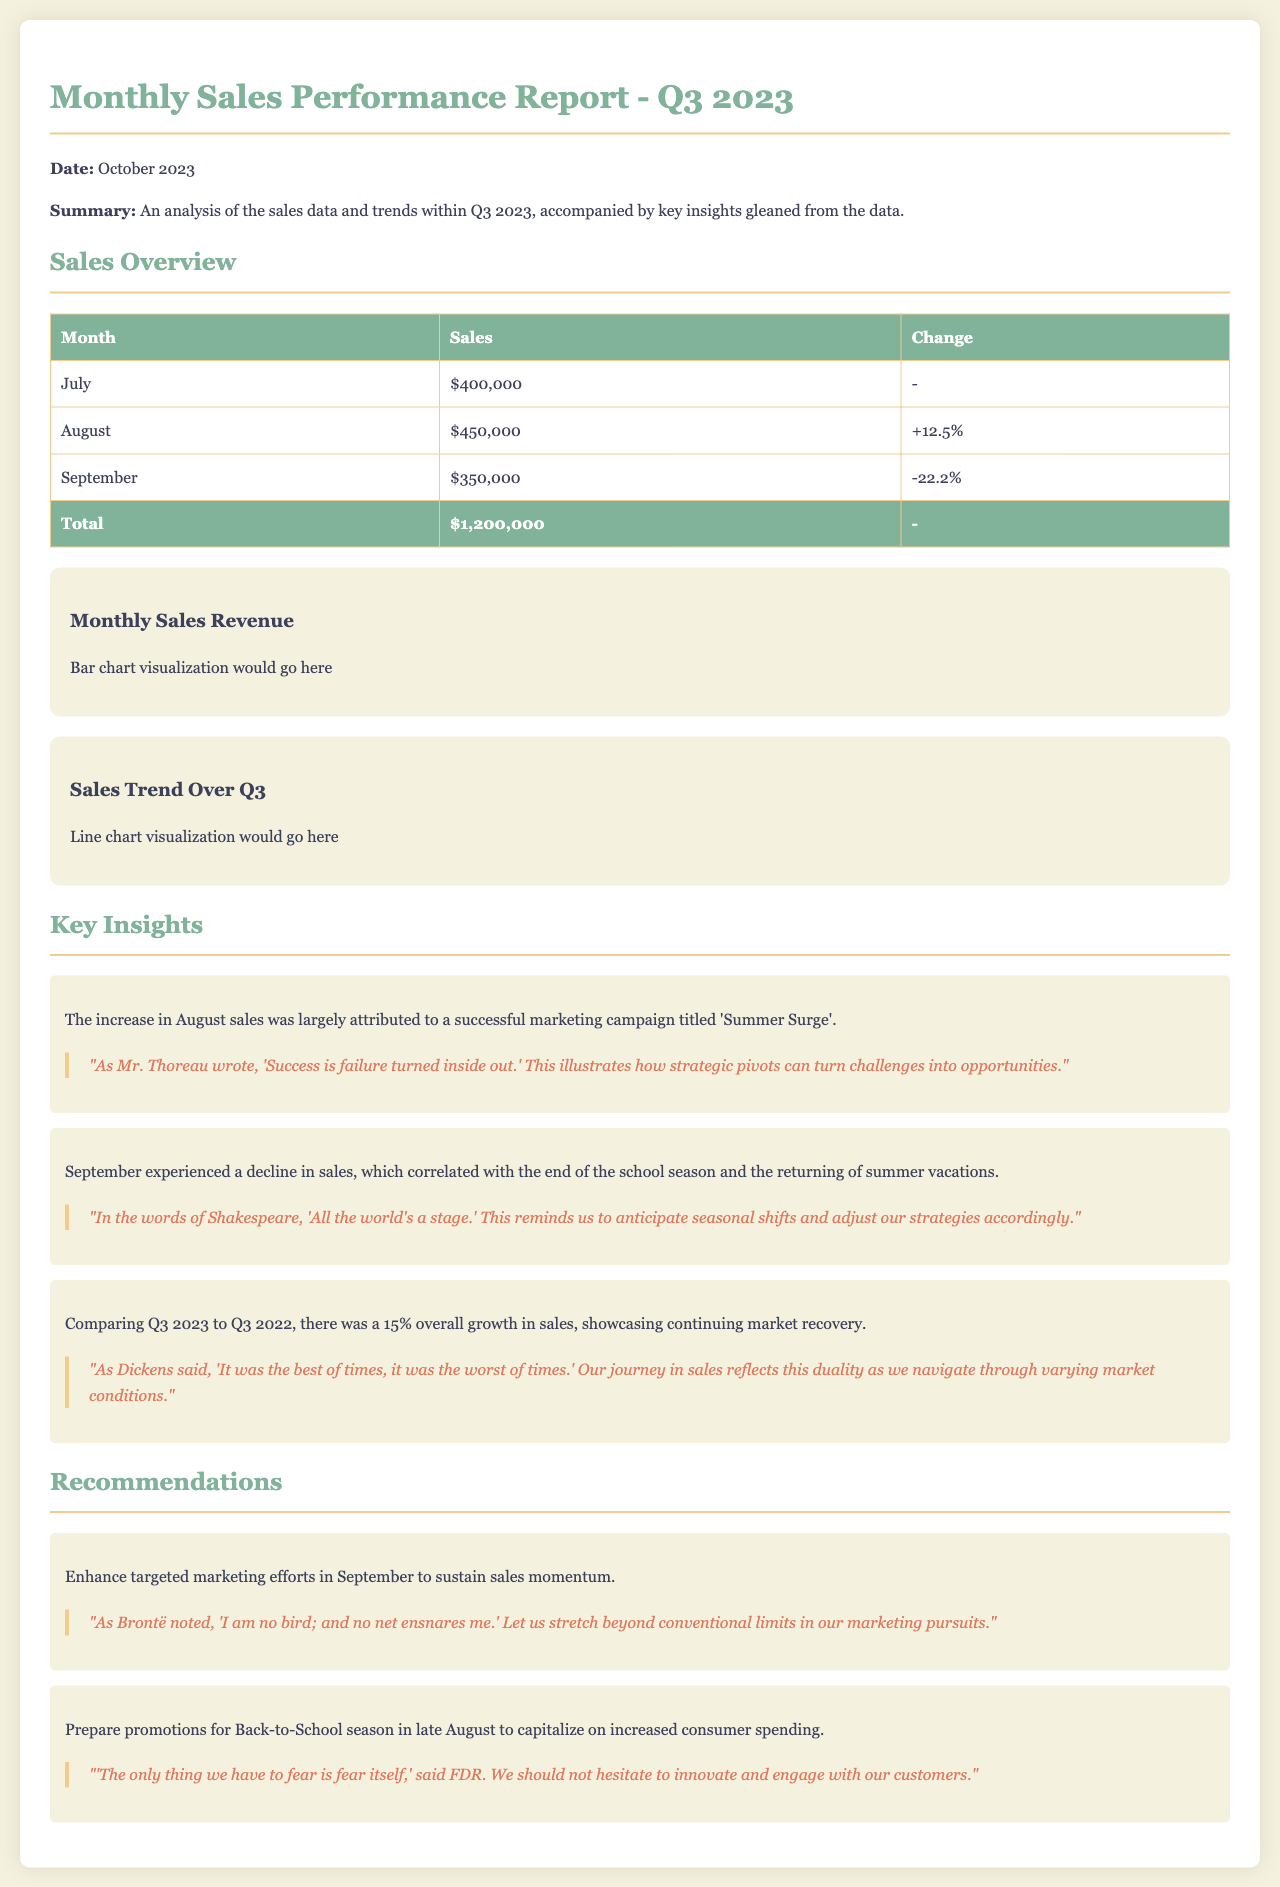What was the total sales for Q3 2023? The total sales is provided in the overview table, which sums up the sales for all three months.
Answer: $1,200,000 What was the sales figure for August? The document specifies the sales for August in the overview table.
Answer: $450,000 Which month had the highest sales? By comparing the sales figures for July, August, and September, we determine which month had the highest sales.
Answer: August What percentage did sales change from August to September? The change in sales from August to September is provided in the overview table, specifically stating the percent decline from one month to the next.
Answer: -22.2% What is the main reason for the increase in August sales? The document states that the increase in August was attributed to a successful marketing campaign.
Answer: 'Summer Surge' What recommendation is given for September? The recommendations section suggests strategies to enhance sales and maintain momentum in September.
Answer: Enhance targeted marketing efforts How does Q3 2023 sales compare to Q3 2022? The document includes a comparative analysis of Q3 2023 with Q3 2022, noting the growth percentage.
Answer: 15% What literary quote accompanies the insight on seasonal sales decline? The insight on September sales references a quote in the document that reflects on shifts and adjustments related to seasons.
Answer: 'All the world's a stage.' What action is suggested for the Back-to-School season? The recommendations section mentions actions to be taken during the Back-to-School season to leverage consumer spending.
Answer: Prepare promotions 